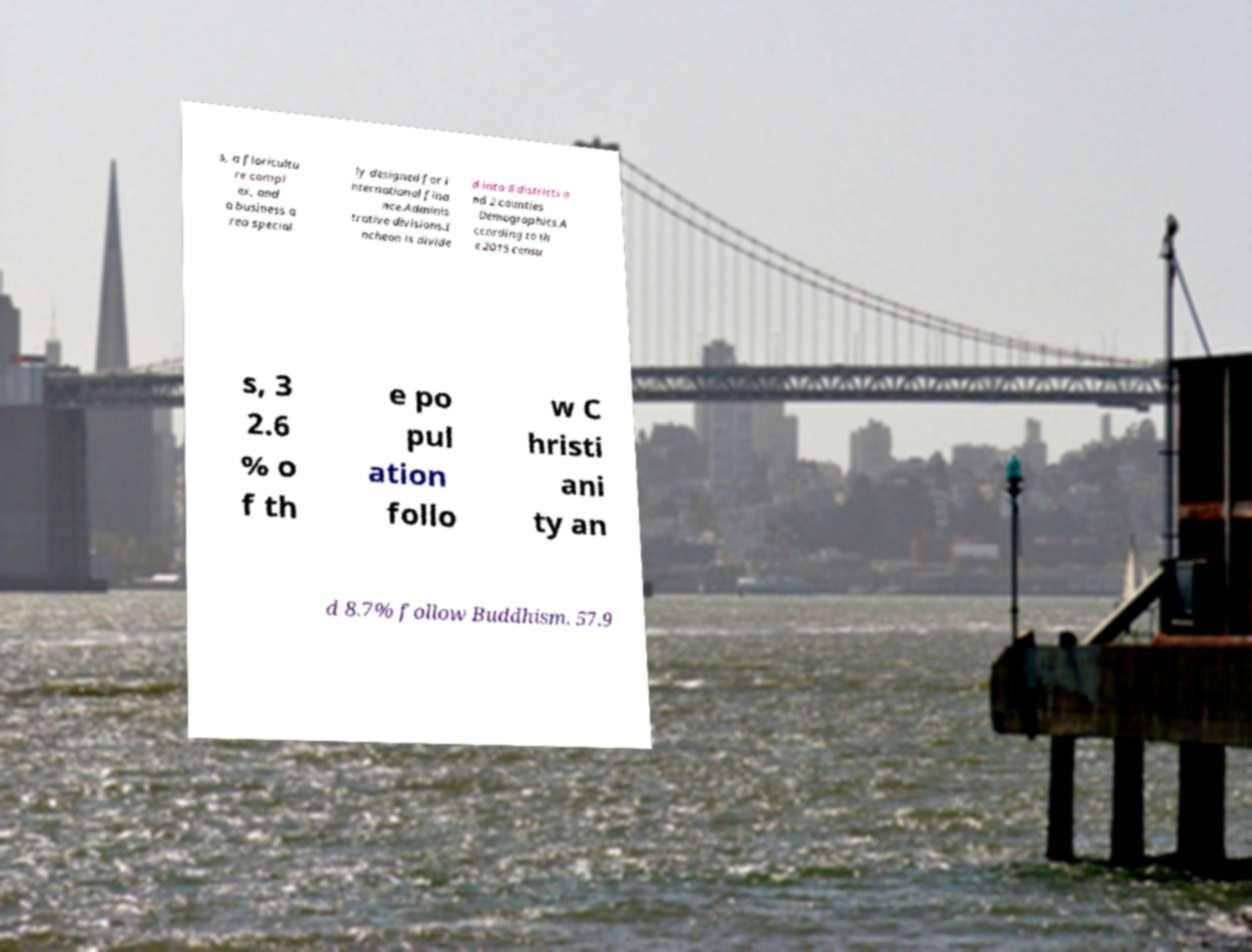Can you read and provide the text displayed in the image?This photo seems to have some interesting text. Can you extract and type it out for me? s, a floricultu re compl ex, and a business a rea special ly designed for i nternational fina nce.Adminis trative divisions.I ncheon is divide d into 8 districts a nd 2 counties .Demographics.A ccording to th e 2015 censu s, 3 2.6 % o f th e po pul ation follo w C hristi ani ty an d 8.7% follow Buddhism. 57.9 